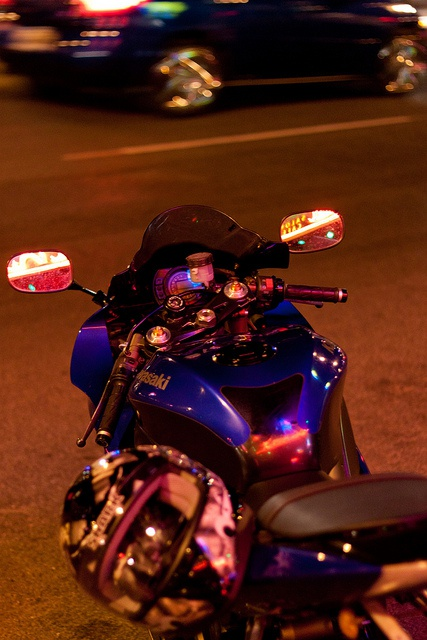Describe the objects in this image and their specific colors. I can see motorcycle in red, black, maroon, navy, and brown tones and car in red, black, maroon, and brown tones in this image. 